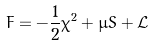Convert formula to latex. <formula><loc_0><loc_0><loc_500><loc_500>F = - \frac { 1 } { 2 } \chi ^ { 2 } + \mu S + \mathcal { L }</formula> 